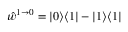Convert formula to latex. <formula><loc_0><loc_0><loc_500><loc_500>\hat { w } ^ { 1 \to 0 } = | 0 \rangle \langle 1 | - | 1 \rangle \langle 1 |</formula> 